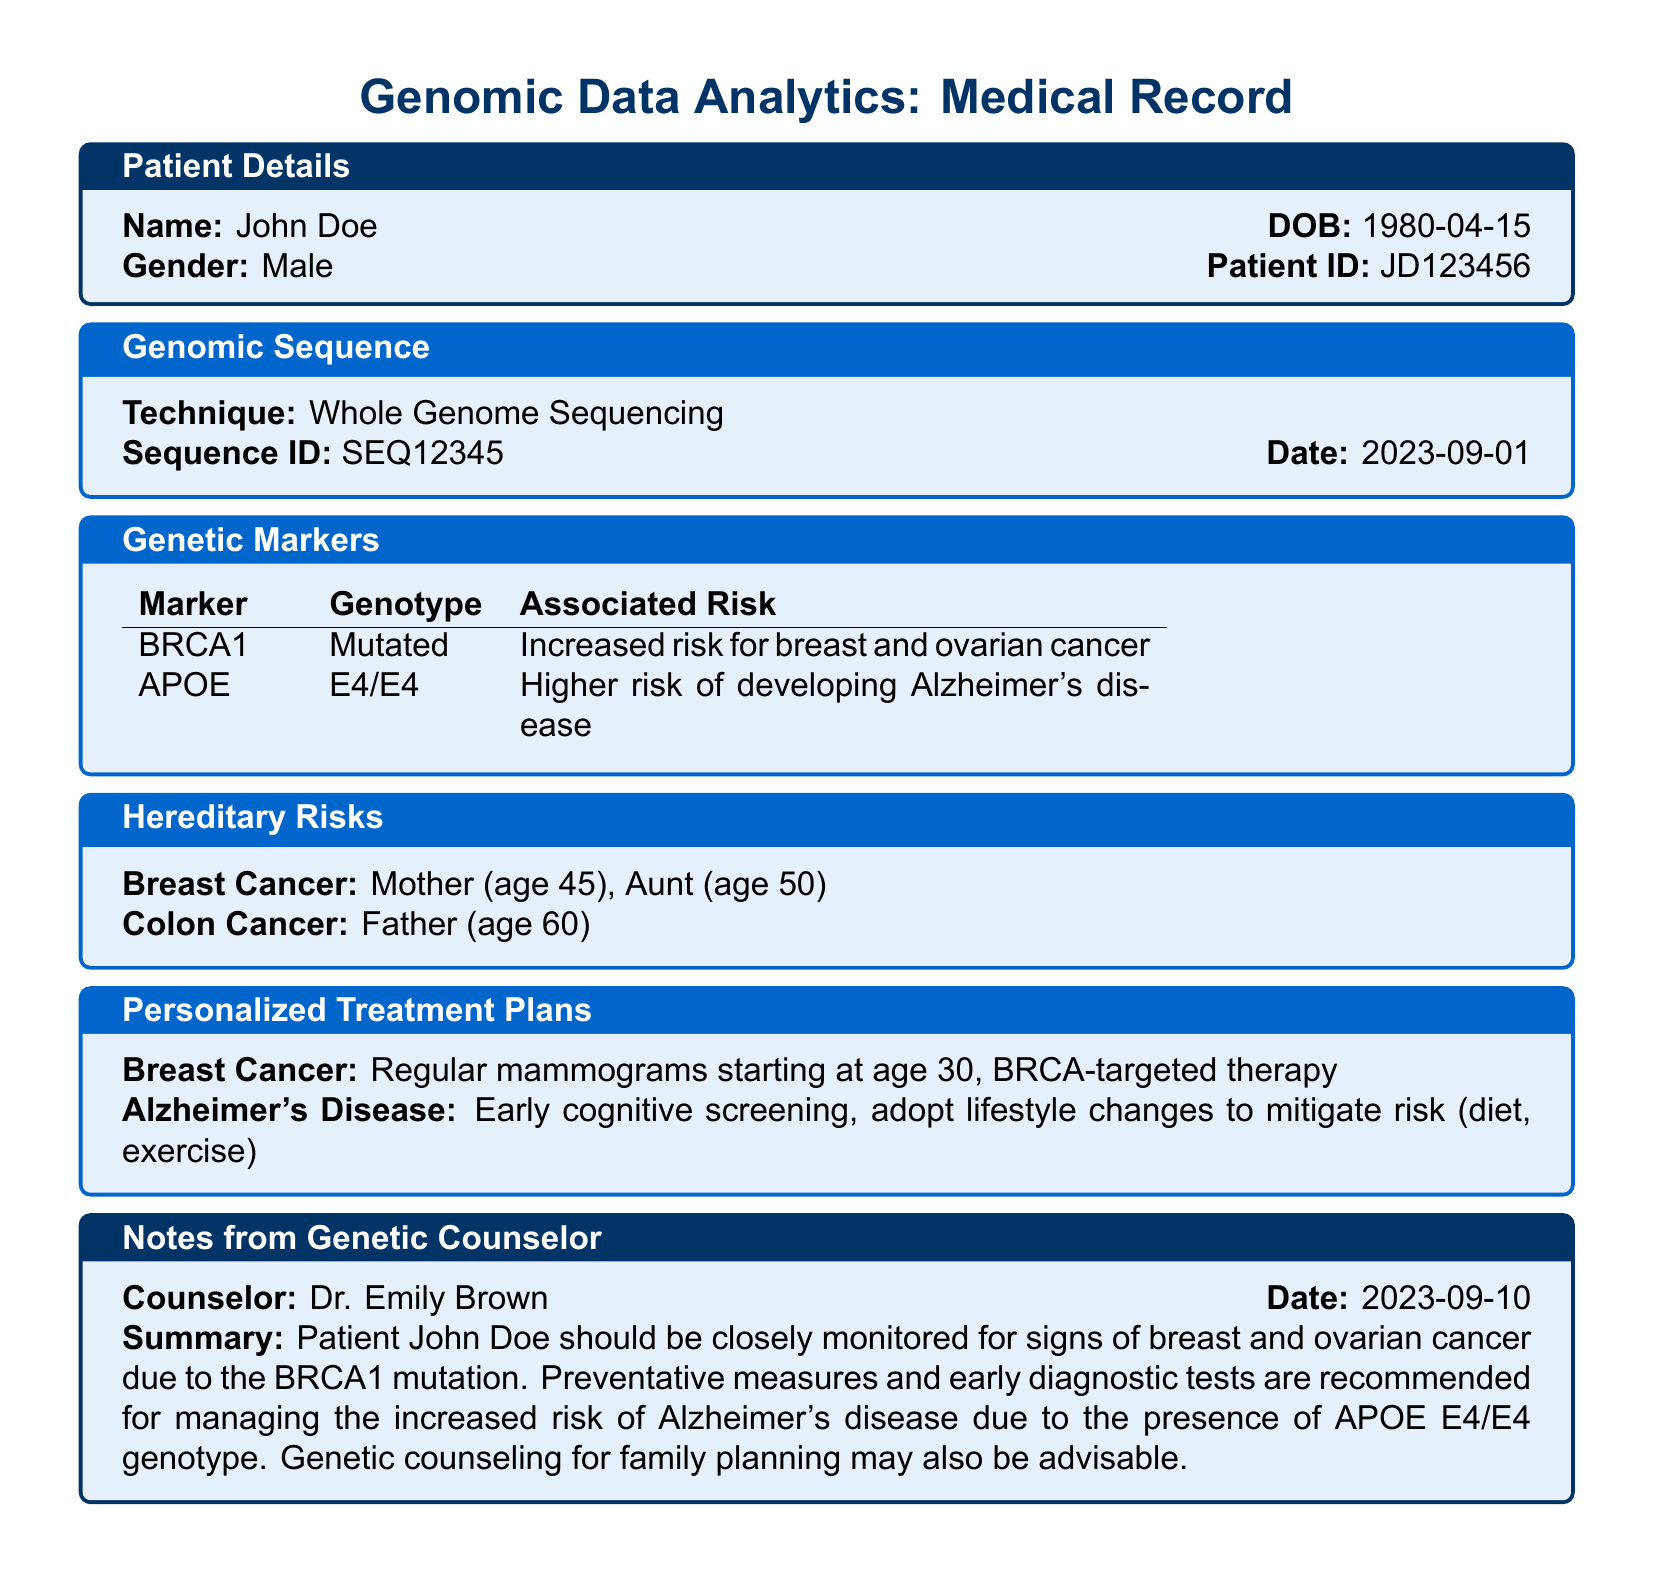What is the patient's name? The patient's name is clearly indicated in the Patient Details section of the document.
Answer: John Doe What is the date of birth of the patient? The date of birth is provided alongside the patient's name in the Patient Details section.
Answer: 1980-04-15 What is the genotype associated with the BRCA1 marker? The genotype for the BRCA1 marker is mentioned in the Genetic Markers section of the document.
Answer: Mutated What potential risk is associated with the APOE gene? The associated risk with the APOE gene is indicated in the Genetic Markers section.
Answer: Higher risk of developing Alzheimer's disease Who is the genetic counselor? The name of the genetic counselor is provided in the Notes from Genetic Counselor section of the document.
Answer: Dr. Emily Brown What treatment is recommended for breast cancer? The suggested treatment for breast cancer is mentioned under the Personalized Treatment Plans section.
Answer: Regular mammograms starting at age 30, BRCA-targeted therapy Why should John Doe be monitored closely? The document notes the specific reasons for close monitoring in relation to genetic factors and family history.
Answer: Due to the BRCA1 mutation What is the family history of breast cancer? The hereditary risks associated with breast cancer are listed in the Hereditary Risks section.
Answer: Mother (age 45), Aunt (age 50) What lifestyle changes are recommended for Alzheimer's disease? The recommended lifestyle changes are detailed in the Personalized Treatment Plans section for managing Alzheimer's risk.
Answer: Diet, exercise What date was the genetic counseling summary created? The date of the genetic counseling summary is recorded in the Notes from Genetic Counselor section.
Answer: 2023-09-10 